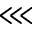Convert formula to latex. <formula><loc_0><loc_0><loc_500><loc_500>\lll</formula> 